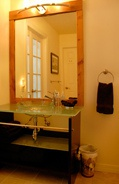Describe the objects in this image and their specific colors. I can see vase in khaki, brown, maroon, and black tones and sink in khaki, olive, tan, and orange tones in this image. 